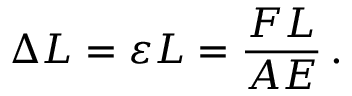Convert formula to latex. <formula><loc_0><loc_0><loc_500><loc_500>\Delta L = \varepsilon L = { \frac { F L } { A E } } \, .</formula> 